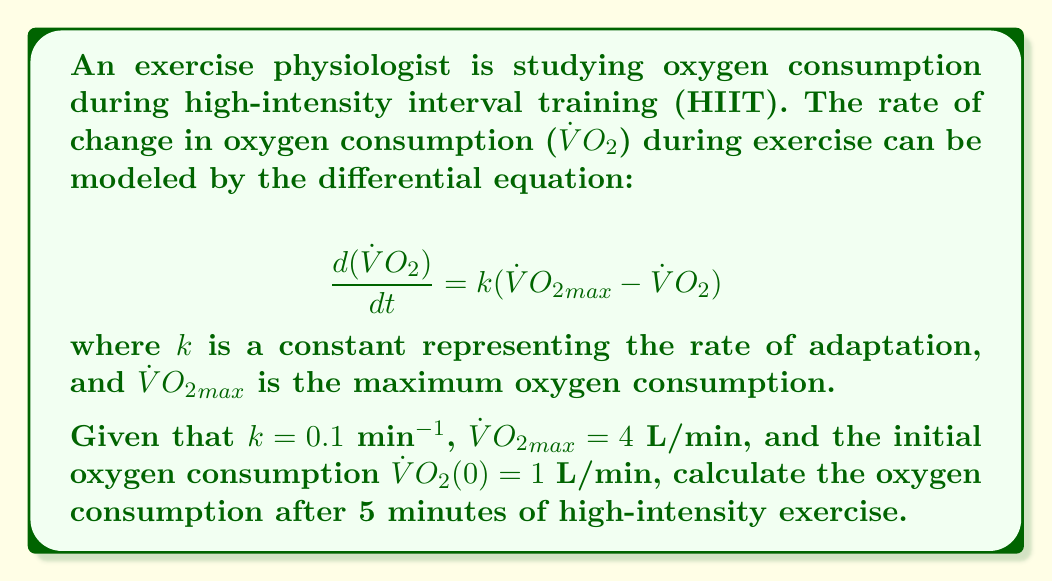Teach me how to tackle this problem. To solve this problem, we need to follow these steps:

1) First, we recognize this as a first-order linear differential equation.

2) The general solution for this type of equation is:

   $$\dot{V}O_2(t) = {\dot{V}O_2}_{max} + ({\dot{V}O_2}_0 - {\dot{V}O_2}_{max})e^{-kt}$$

   where ${\dot{V}O_2}_0$ is the initial oxygen consumption.

3) We're given the following values:
   $k = 0.1$ min^(-1)
   ${\dot{V}O_2}_{max} = 4$ L/min
   ${\dot{V}O_2}_0 = 1$ L/min
   $t = 5$ min

4) Let's substitute these values into our equation:

   $$\dot{V}O_2(5) = 4 + (1 - 4)e^{-0.1 \cdot 5}$$

5) Simplify:
   $$\dot{V}O_2(5) = 4 - 3e^{-0.5}$$

6) Calculate $e^{-0.5} \approx 0.6065$

7) Final calculation:
   $$\dot{V}O_2(5) = 4 - 3 \cdot 0.6065 \approx 2.1805$$

Therefore, after 5 minutes of high-intensity exercise, the oxygen consumption is approximately 2.1805 L/min.
Answer: 2.1805 L/min 